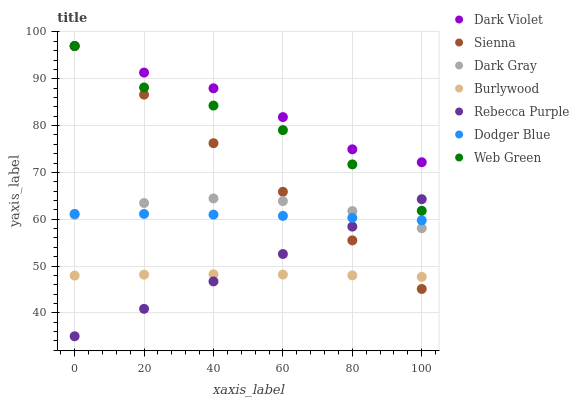Does Burlywood have the minimum area under the curve?
Answer yes or no. Yes. Does Dark Violet have the maximum area under the curve?
Answer yes or no. Yes. Does Web Green have the minimum area under the curve?
Answer yes or no. No. Does Web Green have the maximum area under the curve?
Answer yes or no. No. Is Rebecca Purple the smoothest?
Answer yes or no. Yes. Is Web Green the roughest?
Answer yes or no. Yes. Is Burlywood the smoothest?
Answer yes or no. No. Is Burlywood the roughest?
Answer yes or no. No. Does Rebecca Purple have the lowest value?
Answer yes or no. Yes. Does Web Green have the lowest value?
Answer yes or no. No. Does Sienna have the highest value?
Answer yes or no. Yes. Does Burlywood have the highest value?
Answer yes or no. No. Is Burlywood less than Dark Violet?
Answer yes or no. Yes. Is Dark Violet greater than Rebecca Purple?
Answer yes or no. Yes. Does Sienna intersect Web Green?
Answer yes or no. Yes. Is Sienna less than Web Green?
Answer yes or no. No. Is Sienna greater than Web Green?
Answer yes or no. No. Does Burlywood intersect Dark Violet?
Answer yes or no. No. 